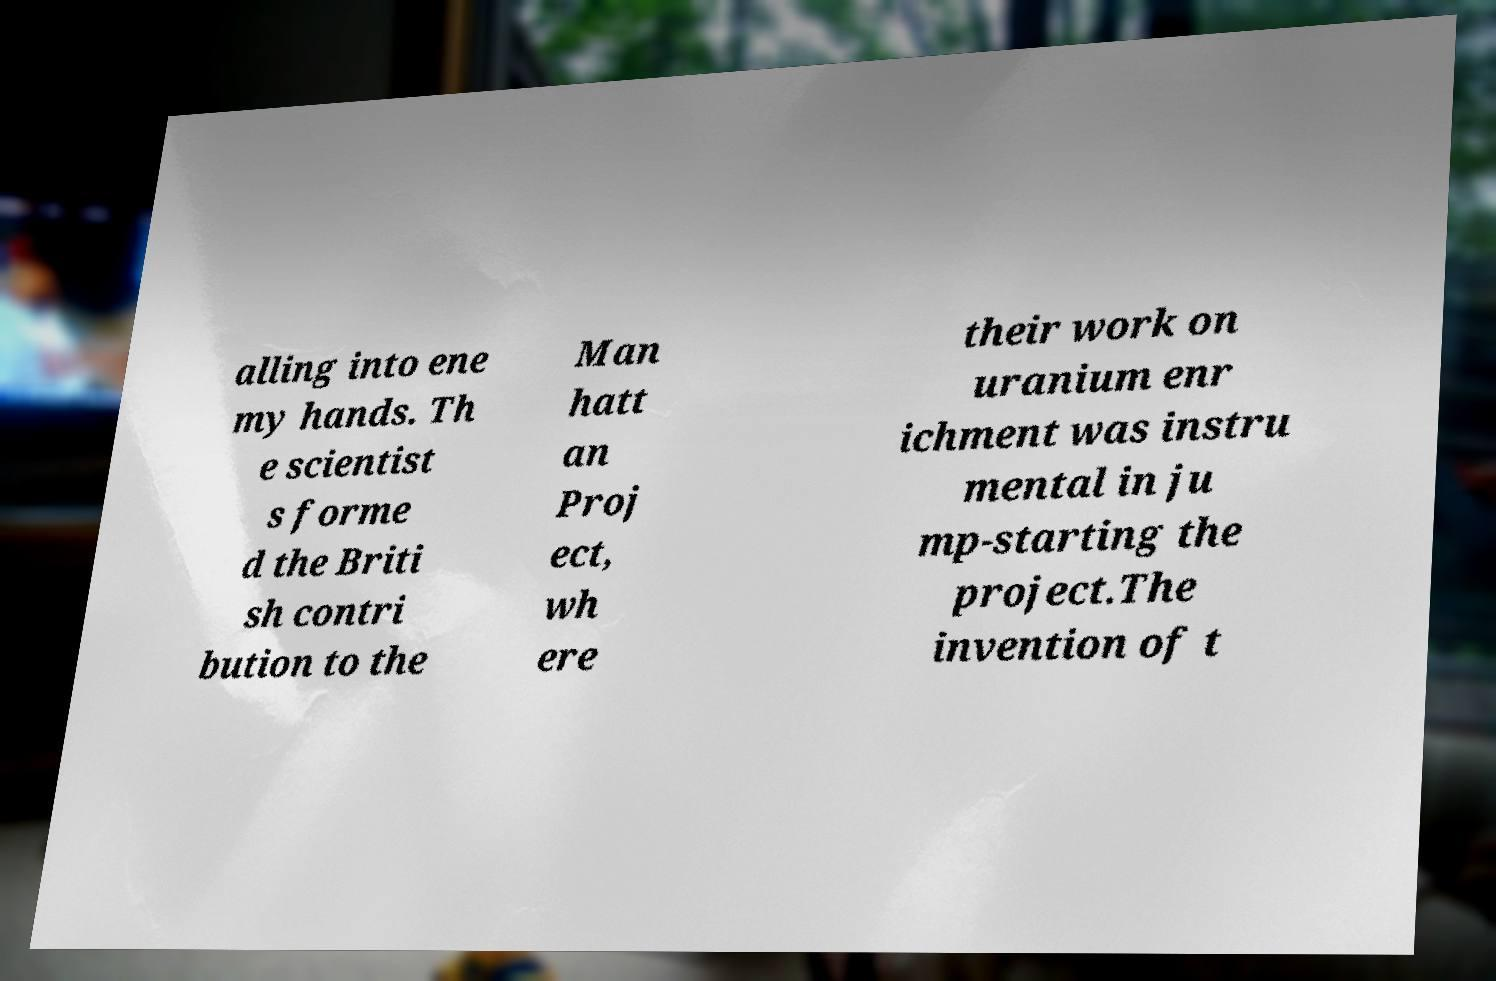There's text embedded in this image that I need extracted. Can you transcribe it verbatim? alling into ene my hands. Th e scientist s forme d the Briti sh contri bution to the Man hatt an Proj ect, wh ere their work on uranium enr ichment was instru mental in ju mp-starting the project.The invention of t 